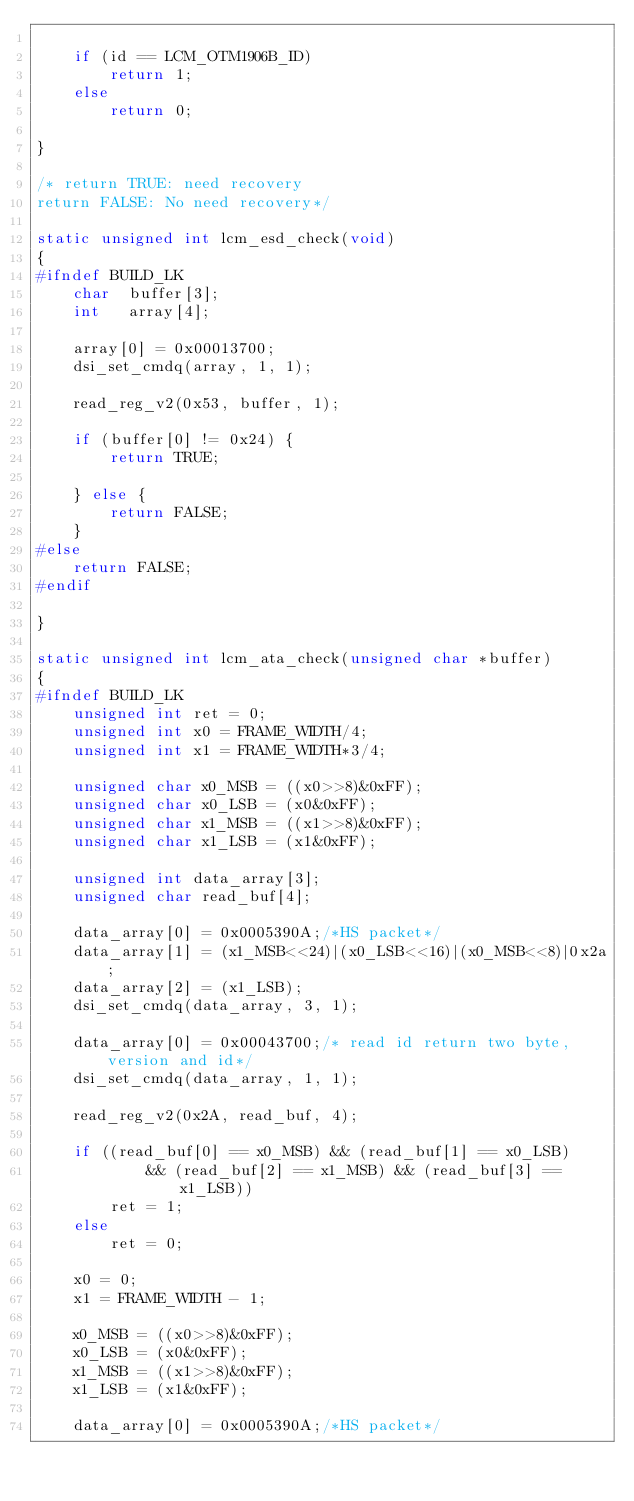Convert code to text. <code><loc_0><loc_0><loc_500><loc_500><_C_>
	if (id == LCM_OTM1906B_ID)
		return 1;
	else
		return 0;

}

/* return TRUE: need recovery
return FALSE: No need recovery*/

static unsigned int lcm_esd_check(void)
{
#ifndef BUILD_LK
	char  buffer[3];
	int   array[4];

	array[0] = 0x00013700;
	dsi_set_cmdq(array, 1, 1);

	read_reg_v2(0x53, buffer, 1);

	if (buffer[0] != 0x24) {
		return TRUE;

	} else {
		return FALSE;
	}
#else
	return FALSE;
#endif

}

static unsigned int lcm_ata_check(unsigned char *buffer)
{
#ifndef BUILD_LK
	unsigned int ret = 0;
	unsigned int x0 = FRAME_WIDTH/4;
	unsigned int x1 = FRAME_WIDTH*3/4;

	unsigned char x0_MSB = ((x0>>8)&0xFF);
	unsigned char x0_LSB = (x0&0xFF);
	unsigned char x1_MSB = ((x1>>8)&0xFF);
	unsigned char x1_LSB = (x1&0xFF);

	unsigned int data_array[3];
	unsigned char read_buf[4];

	data_array[0] = 0x0005390A;/*HS packet*/
	data_array[1] = (x1_MSB<<24)|(x0_LSB<<16)|(x0_MSB<<8)|0x2a;
	data_array[2] = (x1_LSB);
	dsi_set_cmdq(data_array, 3, 1);

	data_array[0] = 0x00043700;/* read id return two byte,version and id*/
	dsi_set_cmdq(data_array, 1, 1);

	read_reg_v2(0x2A, read_buf, 4);

	if ((read_buf[0] == x0_MSB) && (read_buf[1] == x0_LSB)
	        && (read_buf[2] == x1_MSB) && (read_buf[3] == x1_LSB))
		ret = 1;
	else
		ret = 0;

	x0 = 0;
	x1 = FRAME_WIDTH - 1;

	x0_MSB = ((x0>>8)&0xFF);
	x0_LSB = (x0&0xFF);
	x1_MSB = ((x1>>8)&0xFF);
	x1_LSB = (x1&0xFF);

	data_array[0] = 0x0005390A;/*HS packet*/</code> 